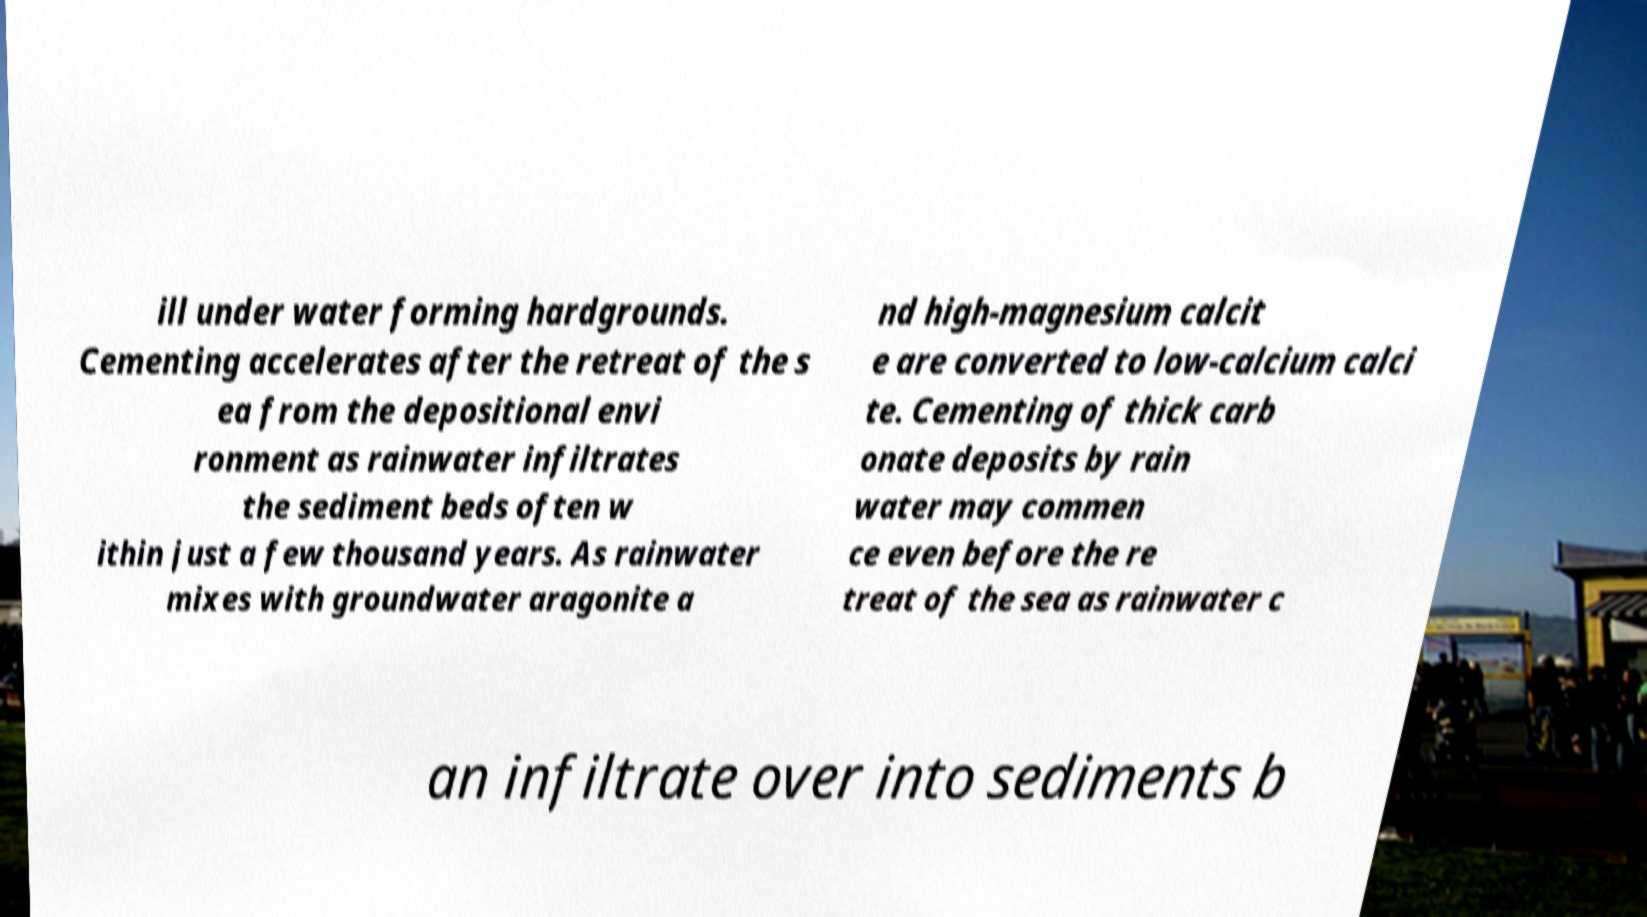Could you assist in decoding the text presented in this image and type it out clearly? ill under water forming hardgrounds. Cementing accelerates after the retreat of the s ea from the depositional envi ronment as rainwater infiltrates the sediment beds often w ithin just a few thousand years. As rainwater mixes with groundwater aragonite a nd high-magnesium calcit e are converted to low-calcium calci te. Cementing of thick carb onate deposits by rain water may commen ce even before the re treat of the sea as rainwater c an infiltrate over into sediments b 